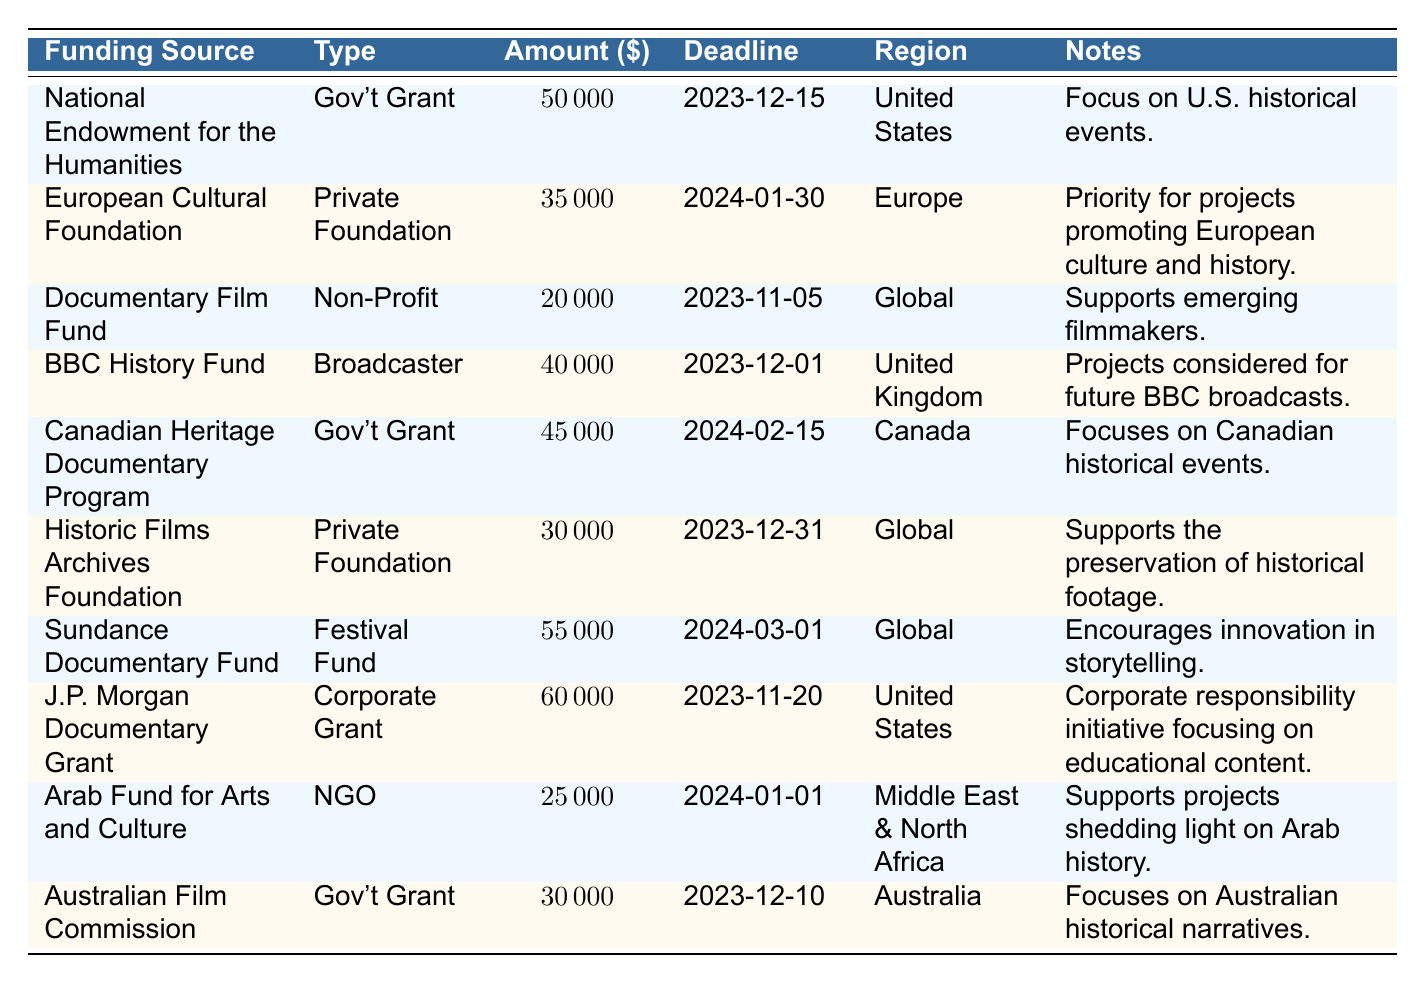What is the funding amount from the J.P. Morgan Documentary Grant? The table lists J.P. Morgan Documentary Grant under the "Funding Source" column, and the corresponding "Amount" is $60,000.
Answer: 60000 Which funding sources have a deadline in December 2023? By checking the "Deadline" column, we see the following deadlines in December 2023: National Endowment for the Humanities (12-15), BBC History Fund (12-01), Historic Films Archives Foundation (12-31), and Australian Film Commission (12-10).
Answer: National Endowment for the Humanities, BBC History Fund, Historic Films Archives Foundation, Australian Film Commission What is the total amount of funding available from all Government Grants? We add the amounts from the Government Grant types listed: National Endowment for the Humanities ($50,000) + Canadian Heritage Documentary Program ($45,000) + Australian Film Commission ($30,000) = $125,000.
Answer: 125000 Does the Documentary Film Fund have a higher funding amount than the Arab Fund for Arts and Culture? The amount for the Documentary Film Fund is $20,000, while the amount for the Arab Fund for Arts and Culture is $25,000. Since $20,000 is less than $25,000, the answer is no.
Answer: No Which funding source has the highest amount, and what is that amount? The highest funding amount listed is from the Sundance Documentary Fund with $55,000. We can identify this by comparing all amounts in the "Amount" column.
Answer: Sundance Documentary Fund; 55000 What percentage of the total funding amounts listed goes to the Canadian Heritage Documentary Program? The total amounts for all funding sources is $50,000 + $35,000 + $20,000 + $40,000 + $45,000 + $30,000 + $55,000 + $60,000 + $25,000 + $30,000 = $390,000. The amount for Canadian Heritage Documentary Program is $45,000. To find the percentage, we calculate (45,000 / 390,000) * 100, which equals approximately 11.54%.
Answer: 11.54% Are there any funding sources focused specifically on U.S. historical events? By looking at the "Notes" section, the National Endowment for the Humanities and J.P. Morgan Documentary Grant mention a focus on U.S. historical events, indicating that there are funding sources specifically for this.
Answer: Yes How many funding sources are available for projects promoting European culture and history? The table shows that there is one funding source specifically for promoting European culture and history, which is the European Cultural Foundation.
Answer: 1 Which funding source has the earliest application deadline, and when is it? By scanning through the "Deadline" column, the earliest application deadline is for the Documentary Film Fund on November 5, 2023.
Answer: Documentary Film Fund; 2023-11-05 